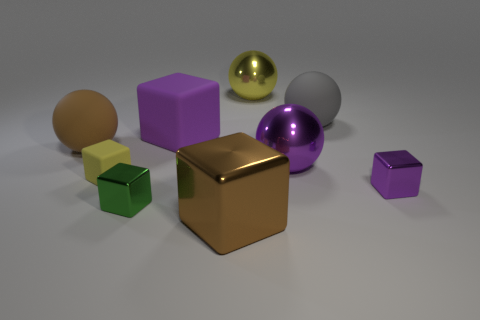There is a big purple thing behind the large brown rubber thing; is it the same shape as the purple metal object that is in front of the small yellow matte cube?
Keep it short and to the point. Yes. There is another rubber thing that is the same shape as the large brown rubber object; what is its color?
Offer a terse response. Gray. What is the shape of the rubber object that is both behind the big brown sphere and on the left side of the gray thing?
Give a very brief answer. Cube. There is a sphere that is made of the same material as the gray thing; what is its color?
Keep it short and to the point. Brown. There is a large brown thing that is left of the small shiny cube to the left of the small shiny cube right of the yellow shiny thing; what shape is it?
Provide a succinct answer. Sphere. How big is the green metal thing?
Your answer should be compact. Small. The big purple object that is the same material as the yellow ball is what shape?
Keep it short and to the point. Sphere. Are there fewer shiny cubes on the right side of the purple shiny ball than yellow rubber things?
Ensure brevity in your answer.  No. There is a tiny metal object in front of the tiny purple thing; what is its color?
Make the answer very short. Green. There is a ball that is the same color as the large shiny block; what is it made of?
Provide a short and direct response. Rubber. 